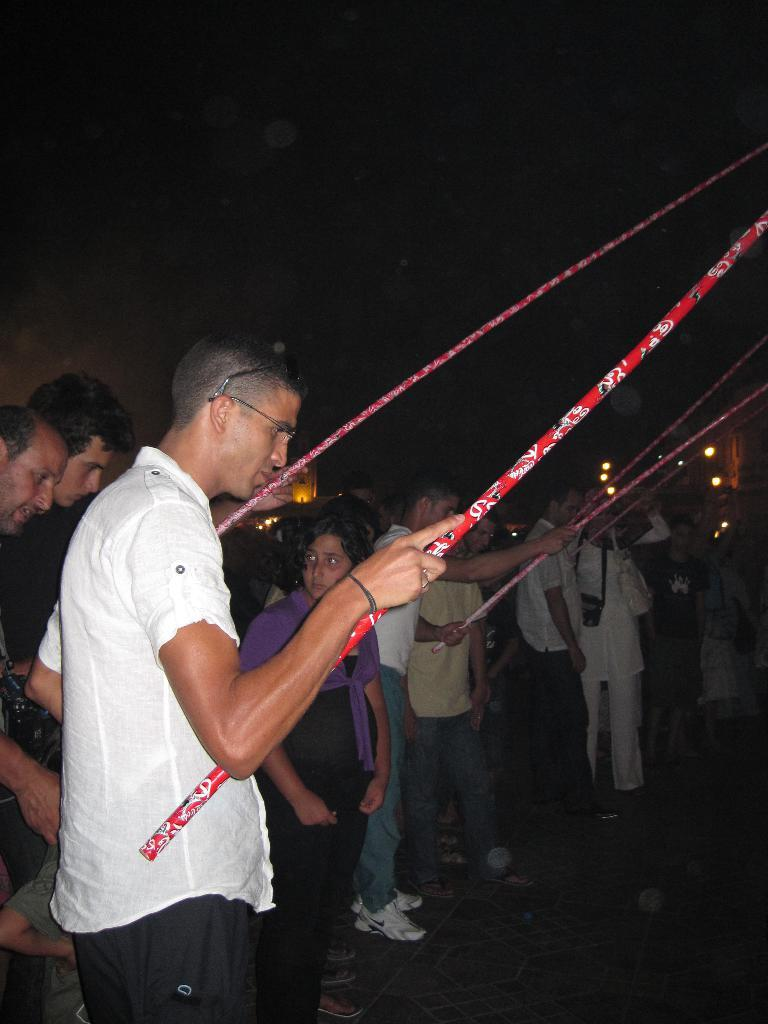How many people are in the image? There is a group of people in the image. What are the people doing in the image? The people are standing on the ground. What are some of the people holding in the image? Some of the people are holding big red sticks. What is the total amount of debt held by the people in the image? There is no information about debt in the image, as it features a group of people standing on the ground and holding big red sticks. 